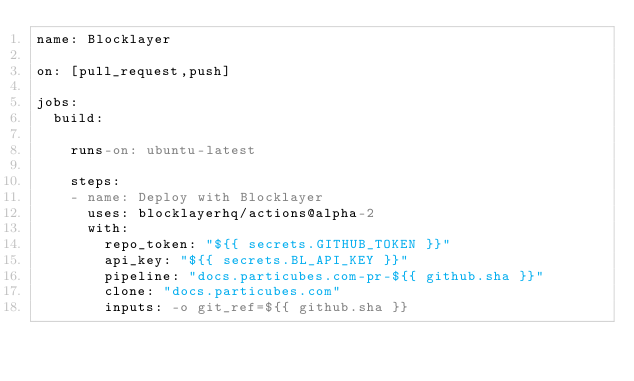Convert code to text. <code><loc_0><loc_0><loc_500><loc_500><_YAML_>name: Blocklayer

on: [pull_request,push]

jobs:
  build:

    runs-on: ubuntu-latest
    
    steps:
    - name: Deploy with Blocklayer
      uses: blocklayerhq/actions@alpha-2
      with:
        repo_token: "${{ secrets.GITHUB_TOKEN }}"
        api_key: "${{ secrets.BL_API_KEY }}"
        pipeline: "docs.particubes.com-pr-${{ github.sha }}"
        clone: "docs.particubes.com"
        inputs: -o git_ref=${{ github.sha }}
</code> 